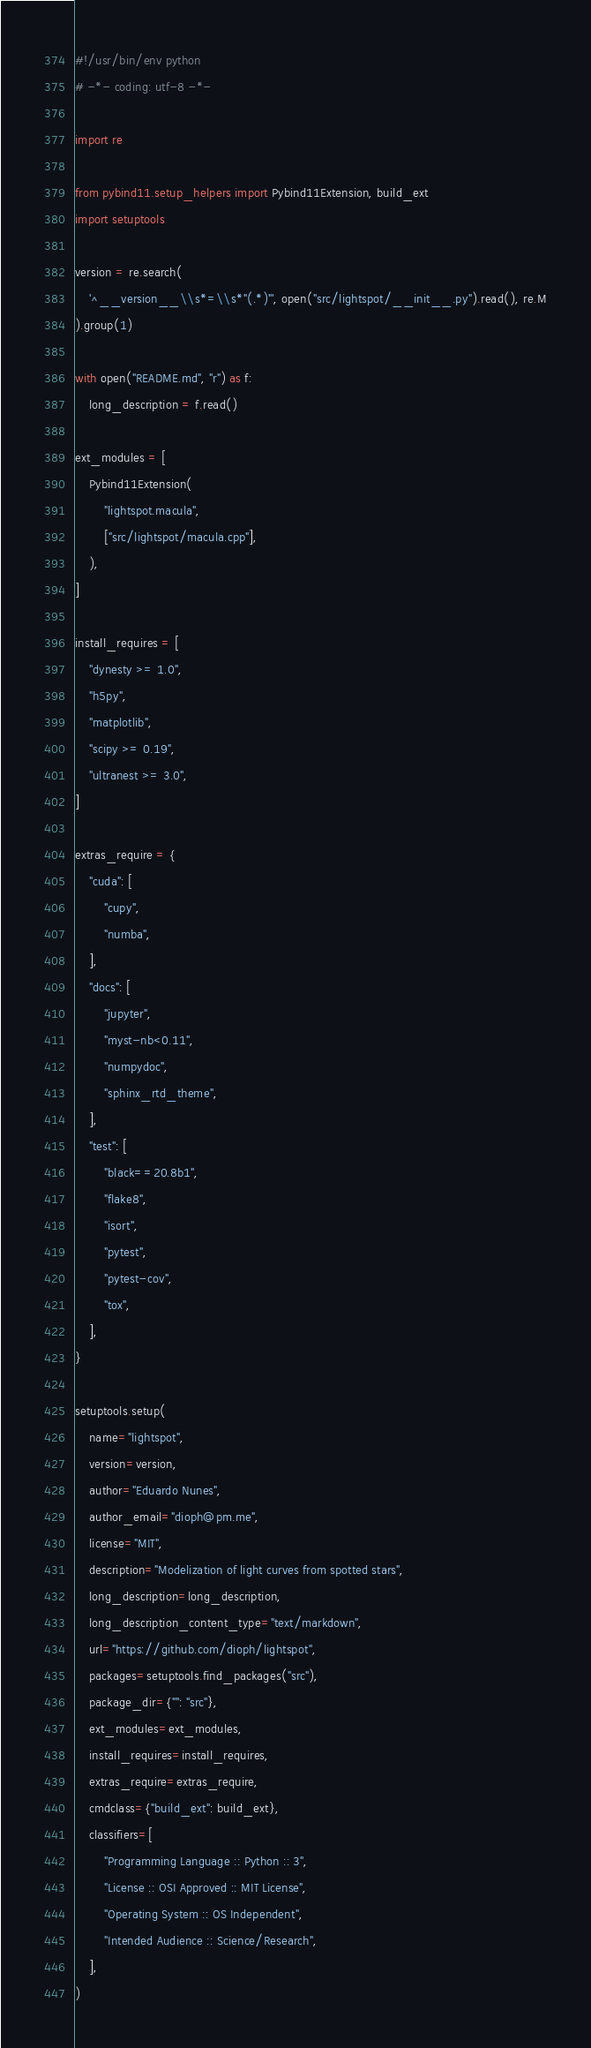Convert code to text. <code><loc_0><loc_0><loc_500><loc_500><_Python_>#!/usr/bin/env python
# -*- coding: utf-8 -*-

import re

from pybind11.setup_helpers import Pybind11Extension, build_ext
import setuptools

version = re.search(
    '^__version__\\s*=\\s*"(.*)"', open("src/lightspot/__init__.py").read(), re.M
).group(1)

with open("README.md", "r") as f:
    long_description = f.read()

ext_modules = [
    Pybind11Extension(
        "lightspot.macula",
        ["src/lightspot/macula.cpp"],
    ),
]

install_requires = [
    "dynesty >= 1.0",
    "h5py",
    "matplotlib",
    "scipy >= 0.19",
    "ultranest >= 3.0",
]

extras_require = {
    "cuda": [
        "cupy",
        "numba",
    ],
    "docs": [
        "jupyter",
        "myst-nb<0.11",
        "numpydoc",
        "sphinx_rtd_theme",
    ],
    "test": [
        "black==20.8b1",
        "flake8",
        "isort",
        "pytest",
        "pytest-cov",
        "tox",
    ],
}

setuptools.setup(
    name="lightspot",
    version=version,
    author="Eduardo Nunes",
    author_email="dioph@pm.me",
    license="MIT",
    description="Modelization of light curves from spotted stars",
    long_description=long_description,
    long_description_content_type="text/markdown",
    url="https://github.com/dioph/lightspot",
    packages=setuptools.find_packages("src"),
    package_dir={"": "src"},
    ext_modules=ext_modules,
    install_requires=install_requires,
    extras_require=extras_require,
    cmdclass={"build_ext": build_ext},
    classifiers=[
        "Programming Language :: Python :: 3",
        "License :: OSI Approved :: MIT License",
        "Operating System :: OS Independent",
        "Intended Audience :: Science/Research",
    ],
)
</code> 